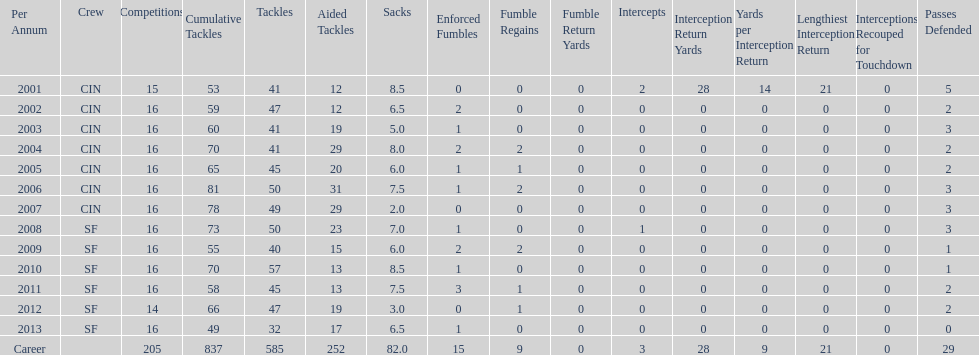In which sole season does he have less than three sacks? 2007. Could you parse the entire table? {'header': ['Per Annum', 'Crew', 'Competitions', 'Cumulative Tackles', 'Tackles', 'Aided Tackles', 'Sacks', 'Enforced Fumbles', 'Fumble Regains', 'Fumble Return Yards', 'Intercepts', 'Interception Return Yards', 'Yards per Interception Return', 'Lengthiest Interception Return', 'Interceptions Recouped for Touchdown', 'Passes Defended'], 'rows': [['2001', 'CIN', '15', '53', '41', '12', '8.5', '0', '0', '0', '2', '28', '14', '21', '0', '5'], ['2002', 'CIN', '16', '59', '47', '12', '6.5', '2', '0', '0', '0', '0', '0', '0', '0', '2'], ['2003', 'CIN', '16', '60', '41', '19', '5.0', '1', '0', '0', '0', '0', '0', '0', '0', '3'], ['2004', 'CIN', '16', '70', '41', '29', '8.0', '2', '2', '0', '0', '0', '0', '0', '0', '2'], ['2005', 'CIN', '16', '65', '45', '20', '6.0', '1', '1', '0', '0', '0', '0', '0', '0', '2'], ['2006', 'CIN', '16', '81', '50', '31', '7.5', '1', '2', '0', '0', '0', '0', '0', '0', '3'], ['2007', 'CIN', '16', '78', '49', '29', '2.0', '0', '0', '0', '0', '0', '0', '0', '0', '3'], ['2008', 'SF', '16', '73', '50', '23', '7.0', '1', '0', '0', '1', '0', '0', '0', '0', '3'], ['2009', 'SF', '16', '55', '40', '15', '6.0', '2', '2', '0', '0', '0', '0', '0', '0', '1'], ['2010', 'SF', '16', '70', '57', '13', '8.5', '1', '0', '0', '0', '0', '0', '0', '0', '1'], ['2011', 'SF', '16', '58', '45', '13', '7.5', '3', '1', '0', '0', '0', '0', '0', '0', '2'], ['2012', 'SF', '14', '66', '47', '19', '3.0', '0', '1', '0', '0', '0', '0', '0', '0', '2'], ['2013', 'SF', '16', '49', '32', '17', '6.5', '1', '0', '0', '0', '0', '0', '0', '0', '0'], ['Career', '', '205', '837', '585', '252', '82.0', '15', '9', '0', '3', '28', '9', '21', '0', '29']]} 